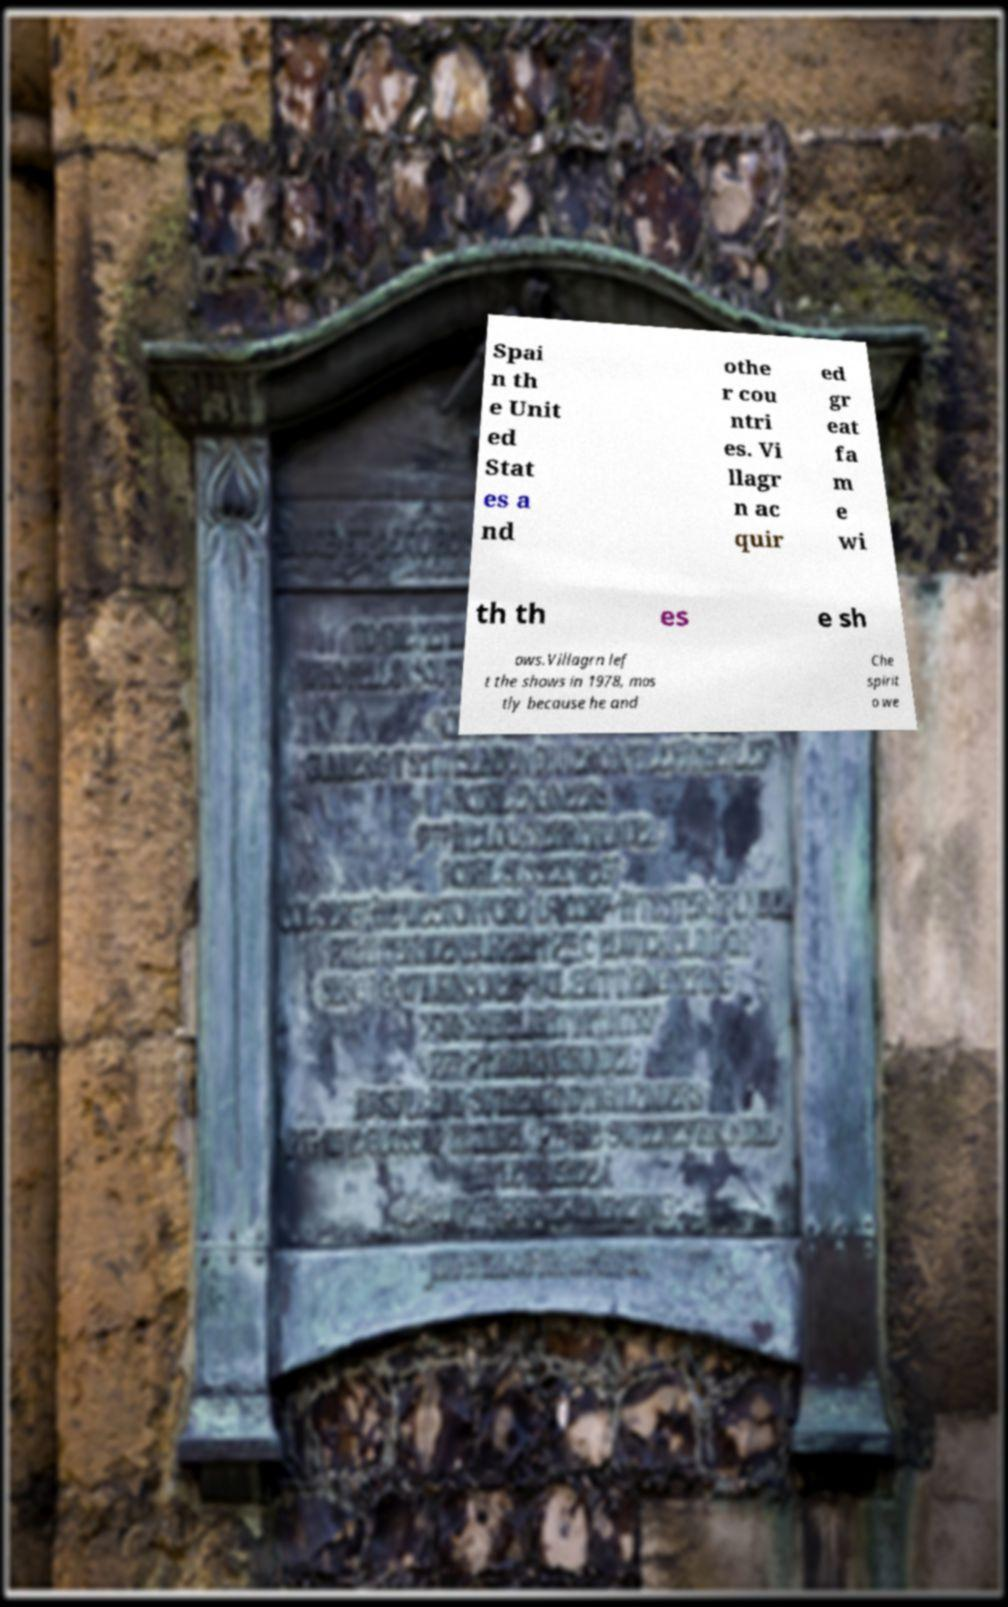What messages or text are displayed in this image? I need them in a readable, typed format. Spai n th e Unit ed Stat es a nd othe r cou ntri es. Vi llagr n ac quir ed gr eat fa m e wi th th es e sh ows.Villagrn lef t the shows in 1978, mos tly because he and Che spirit o we 